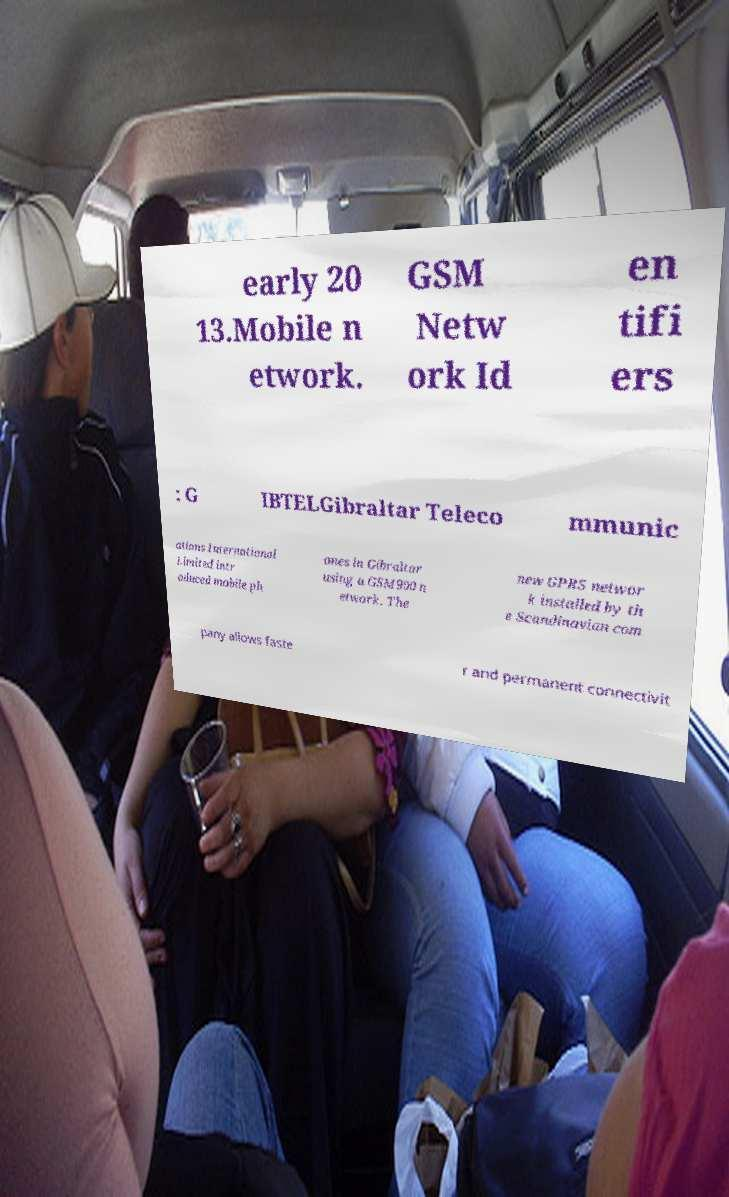Can you read and provide the text displayed in the image?This photo seems to have some interesting text. Can you extract and type it out for me? early 20 13.Mobile n etwork. GSM Netw ork Id en tifi ers : G IBTELGibraltar Teleco mmunic ations International Limited intr oduced mobile ph ones in Gibraltar using a GSM900 n etwork. The new GPRS networ k installed by th e Scandinavian com pany allows faste r and permanent connectivit 